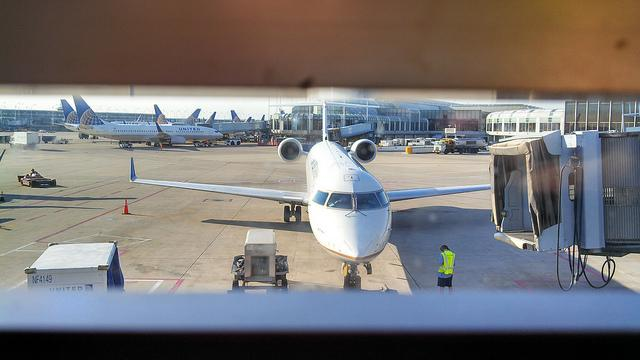What is the large vehicle here? airplane 